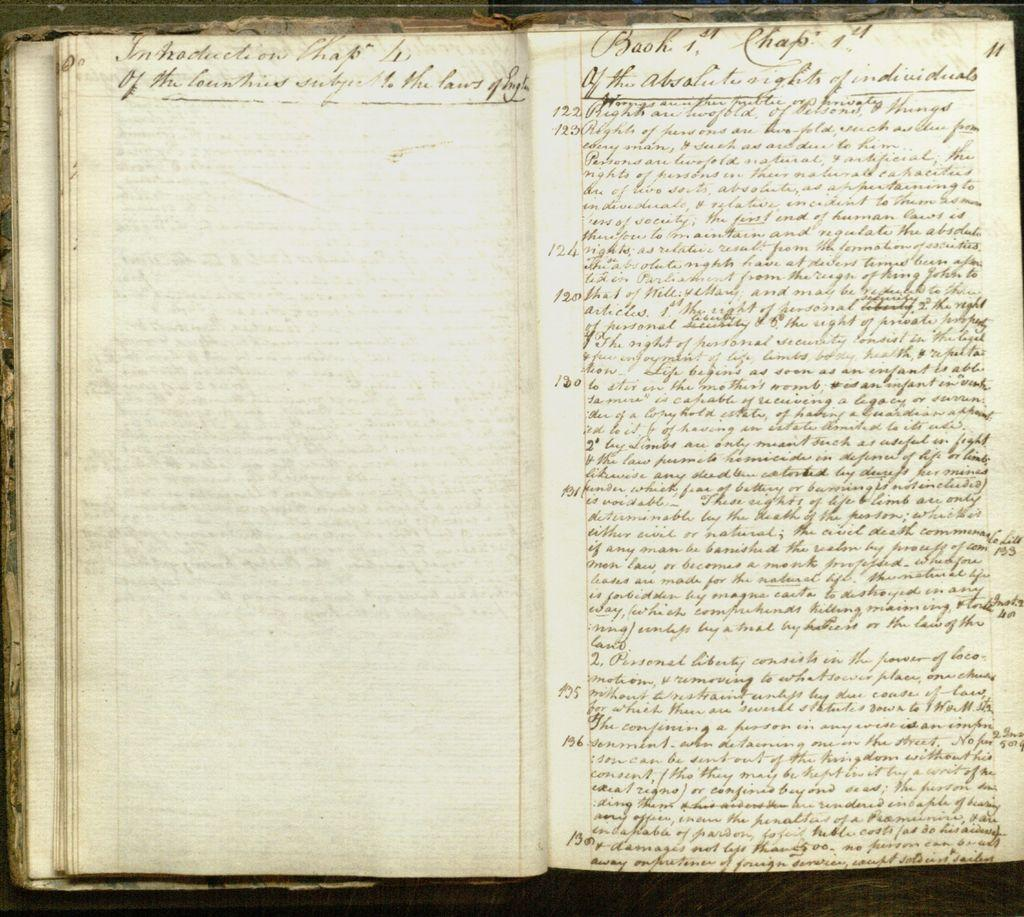What object is present in the image? There is a book in the image. What is the color of the pages in the book? The pages of the book are cream in color. What color is used for writing in the book? Something is written in the book with black color. What type of drink is being offered by the partner in the image? There is no partner or drink present in the image; it only features a book with cream-colored pages and something written in black. 